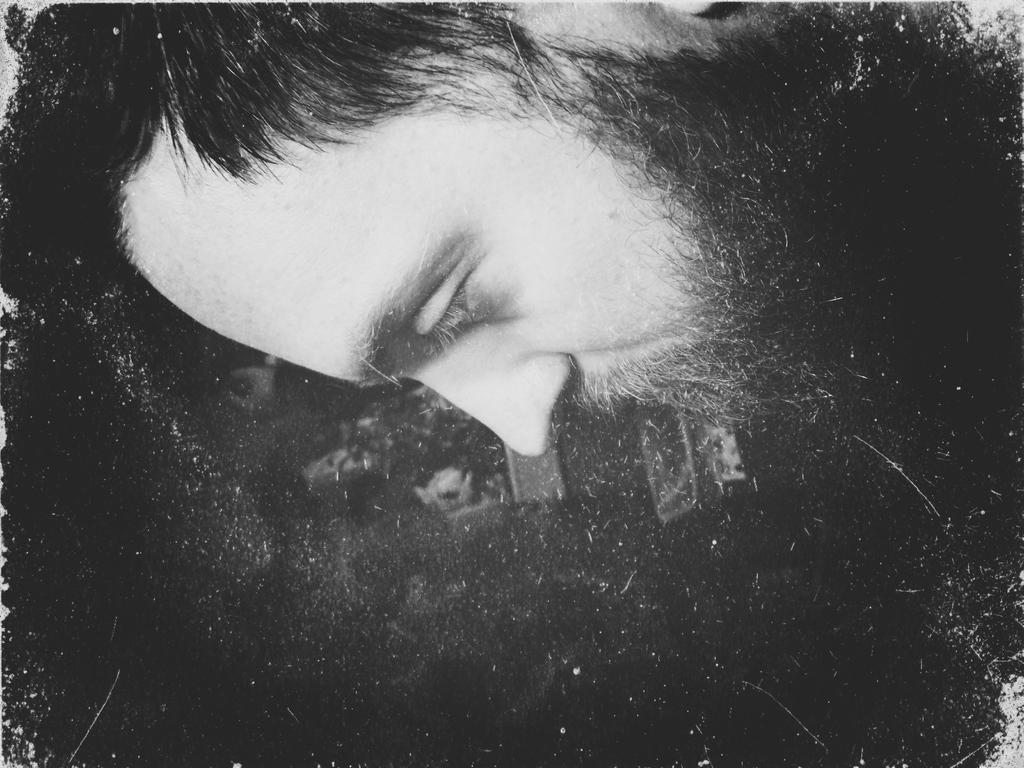Please provide a concise description of this image. In this image we can see black and white picture of a person. 